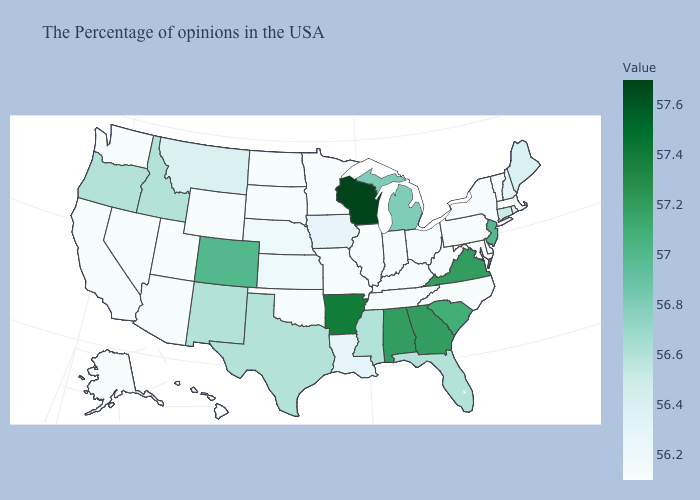Which states have the lowest value in the USA?
Write a very short answer. Massachusetts, Vermont, New York, Delaware, Maryland, Pennsylvania, North Carolina, West Virginia, Ohio, Kentucky, Indiana, Tennessee, Illinois, Missouri, Minnesota, Oklahoma, South Dakota, North Dakota, Wyoming, Utah, Arizona, Nevada, California, Washington, Alaska, Hawaii. Among the states that border North Dakota , which have the lowest value?
Short answer required. Minnesota, South Dakota. Is the legend a continuous bar?
Keep it brief. Yes. Which states hav the highest value in the Northeast?
Short answer required. New Jersey. Which states hav the highest value in the Northeast?
Keep it brief. New Jersey. Does the map have missing data?
Quick response, please. No. 